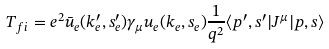Convert formula to latex. <formula><loc_0><loc_0><loc_500><loc_500>T _ { f i } = e ^ { 2 } \bar { u } _ { e } ( k ^ { \prime } _ { e } , s ^ { \prime } _ { e } ) \gamma _ { \mu } u _ { e } ( k _ { e } , s _ { e } ) \frac { 1 } { q ^ { 2 } } \langle p ^ { \prime } , s ^ { \prime } | J ^ { \mu } | p , s \rangle</formula> 